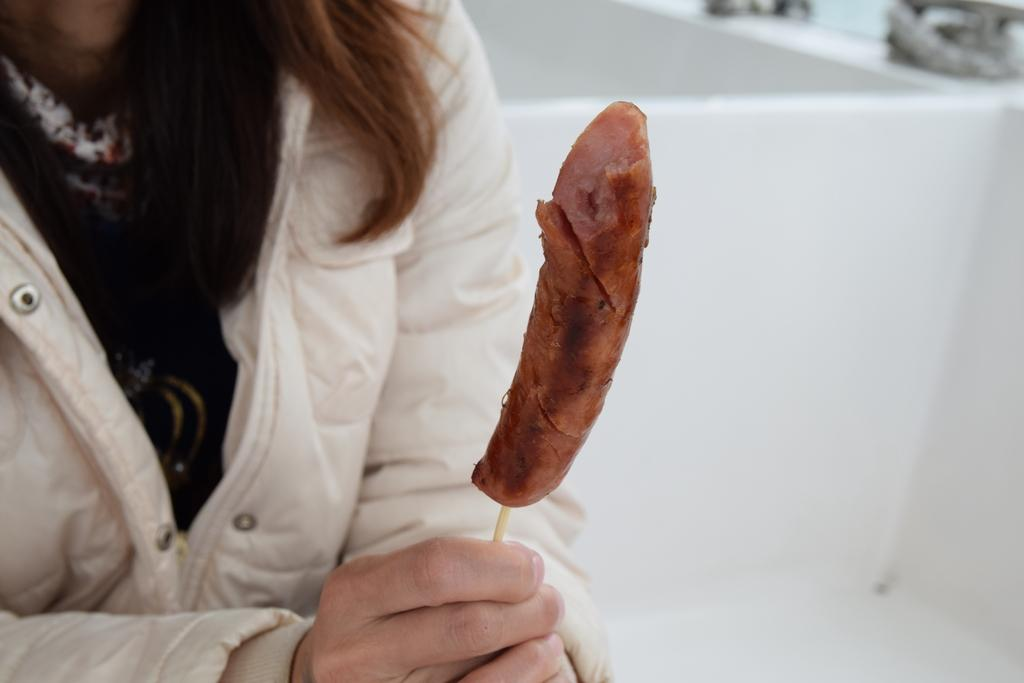Who or what is the main subject of the image? There is a person in the image. What else can be seen in the image besides the person? There is food in the image, and the background contains some objects. Can you describe the quality of the image? The image is blurry. How many boys are participating in the activity shown in the image? There is no activity or boys present in the image; it features a person and food in a blurry setting. 